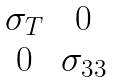<formula> <loc_0><loc_0><loc_500><loc_500>\begin{matrix} \sigma _ { T } & 0 \\ 0 & \sigma _ { 3 3 } \end{matrix}</formula> 